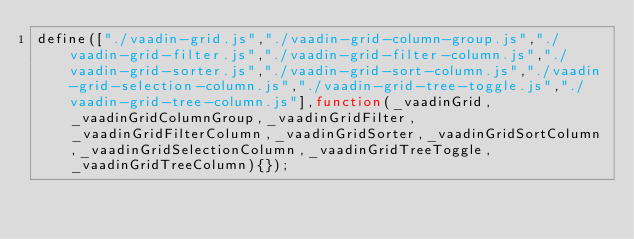<code> <loc_0><loc_0><loc_500><loc_500><_JavaScript_>define(["./vaadin-grid.js","./vaadin-grid-column-group.js","./vaadin-grid-filter.js","./vaadin-grid-filter-column.js","./vaadin-grid-sorter.js","./vaadin-grid-sort-column.js","./vaadin-grid-selection-column.js","./vaadin-grid-tree-toggle.js","./vaadin-grid-tree-column.js"],function(_vaadinGrid,_vaadinGridColumnGroup,_vaadinGridFilter,_vaadinGridFilterColumn,_vaadinGridSorter,_vaadinGridSortColumn,_vaadinGridSelectionColumn,_vaadinGridTreeToggle,_vaadinGridTreeColumn){});</code> 